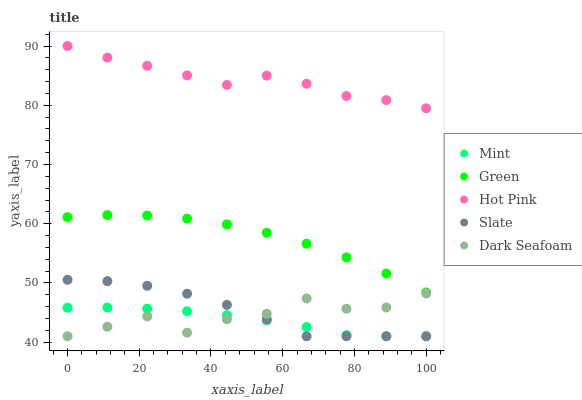Does Mint have the minimum area under the curve?
Answer yes or no. Yes. Does Hot Pink have the maximum area under the curve?
Answer yes or no. Yes. Does Slate have the minimum area under the curve?
Answer yes or no. No. Does Slate have the maximum area under the curve?
Answer yes or no. No. Is Mint the smoothest?
Answer yes or no. Yes. Is Dark Seafoam the roughest?
Answer yes or no. Yes. Is Slate the smoothest?
Answer yes or no. No. Is Slate the roughest?
Answer yes or no. No. Does Slate have the lowest value?
Answer yes or no. Yes. Does Hot Pink have the lowest value?
Answer yes or no. No. Does Hot Pink have the highest value?
Answer yes or no. Yes. Does Slate have the highest value?
Answer yes or no. No. Is Slate less than Green?
Answer yes or no. Yes. Is Hot Pink greater than Green?
Answer yes or no. Yes. Does Slate intersect Dark Seafoam?
Answer yes or no. Yes. Is Slate less than Dark Seafoam?
Answer yes or no. No. Is Slate greater than Dark Seafoam?
Answer yes or no. No. Does Slate intersect Green?
Answer yes or no. No. 